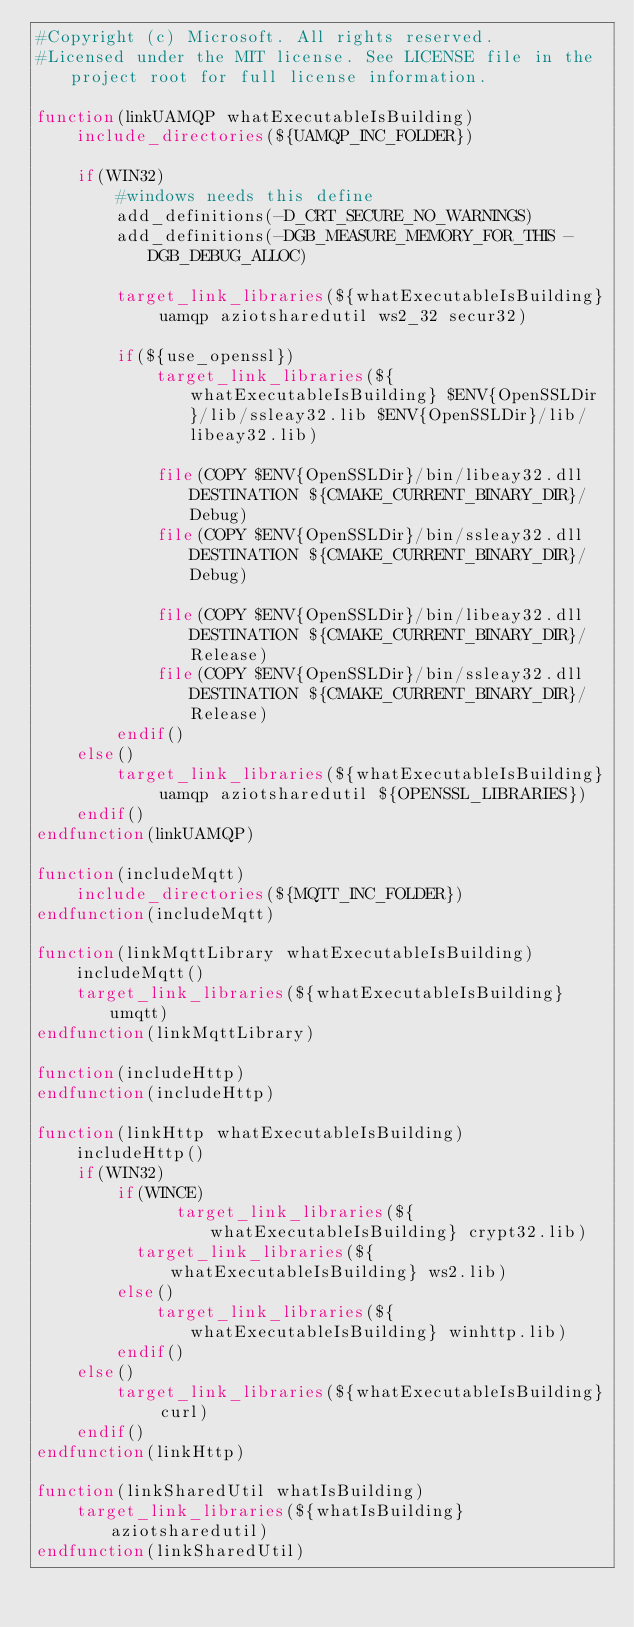Convert code to text. <code><loc_0><loc_0><loc_500><loc_500><_CMake_>#Copyright (c) Microsoft. All rights reserved.
#Licensed under the MIT license. See LICENSE file in the project root for full license information.

function(linkUAMQP whatExecutableIsBuilding)
    include_directories(${UAMQP_INC_FOLDER})
    
    if(WIN32)
        #windows needs this define
        add_definitions(-D_CRT_SECURE_NO_WARNINGS)
        add_definitions(-DGB_MEASURE_MEMORY_FOR_THIS -DGB_DEBUG_ALLOC)

        target_link_libraries(${whatExecutableIsBuilding} uamqp aziotsharedutil ws2_32 secur32)

        if(${use_openssl})
            target_link_libraries(${whatExecutableIsBuilding} $ENV{OpenSSLDir}/lib/ssleay32.lib $ENV{OpenSSLDir}/lib/libeay32.lib)
        
            file(COPY $ENV{OpenSSLDir}/bin/libeay32.dll DESTINATION ${CMAKE_CURRENT_BINARY_DIR}/Debug)
            file(COPY $ENV{OpenSSLDir}/bin/ssleay32.dll DESTINATION ${CMAKE_CURRENT_BINARY_DIR}/Debug)

            file(COPY $ENV{OpenSSLDir}/bin/libeay32.dll DESTINATION ${CMAKE_CURRENT_BINARY_DIR}/Release)
            file(COPY $ENV{OpenSSLDir}/bin/ssleay32.dll DESTINATION ${CMAKE_CURRENT_BINARY_DIR}/Release)
        endif()
    else()
        target_link_libraries(${whatExecutableIsBuilding} uamqp aziotsharedutil ${OPENSSL_LIBRARIES})
    endif()
endfunction(linkUAMQP)

function(includeMqtt)
    include_directories(${MQTT_INC_FOLDER})
endfunction(includeMqtt)

function(linkMqttLibrary whatExecutableIsBuilding)
    includeMqtt()
    target_link_libraries(${whatExecutableIsBuilding} umqtt)
endfunction(linkMqttLibrary)

function(includeHttp)
endfunction(includeHttp)

function(linkHttp whatExecutableIsBuilding)
    includeHttp()
    if(WIN32)
        if(WINCE)
              target_link_libraries(${whatExecutableIsBuilding} crypt32.lib)
          target_link_libraries(${whatExecutableIsBuilding} ws2.lib)
        else()
            target_link_libraries(${whatExecutableIsBuilding} winhttp.lib)
        endif()
    else()
        target_link_libraries(${whatExecutableIsBuilding} curl)
    endif()
endfunction(linkHttp)

function(linkSharedUtil whatIsBuilding)
    target_link_libraries(${whatIsBuilding} aziotsharedutil)
endfunction(linkSharedUtil)
</code> 